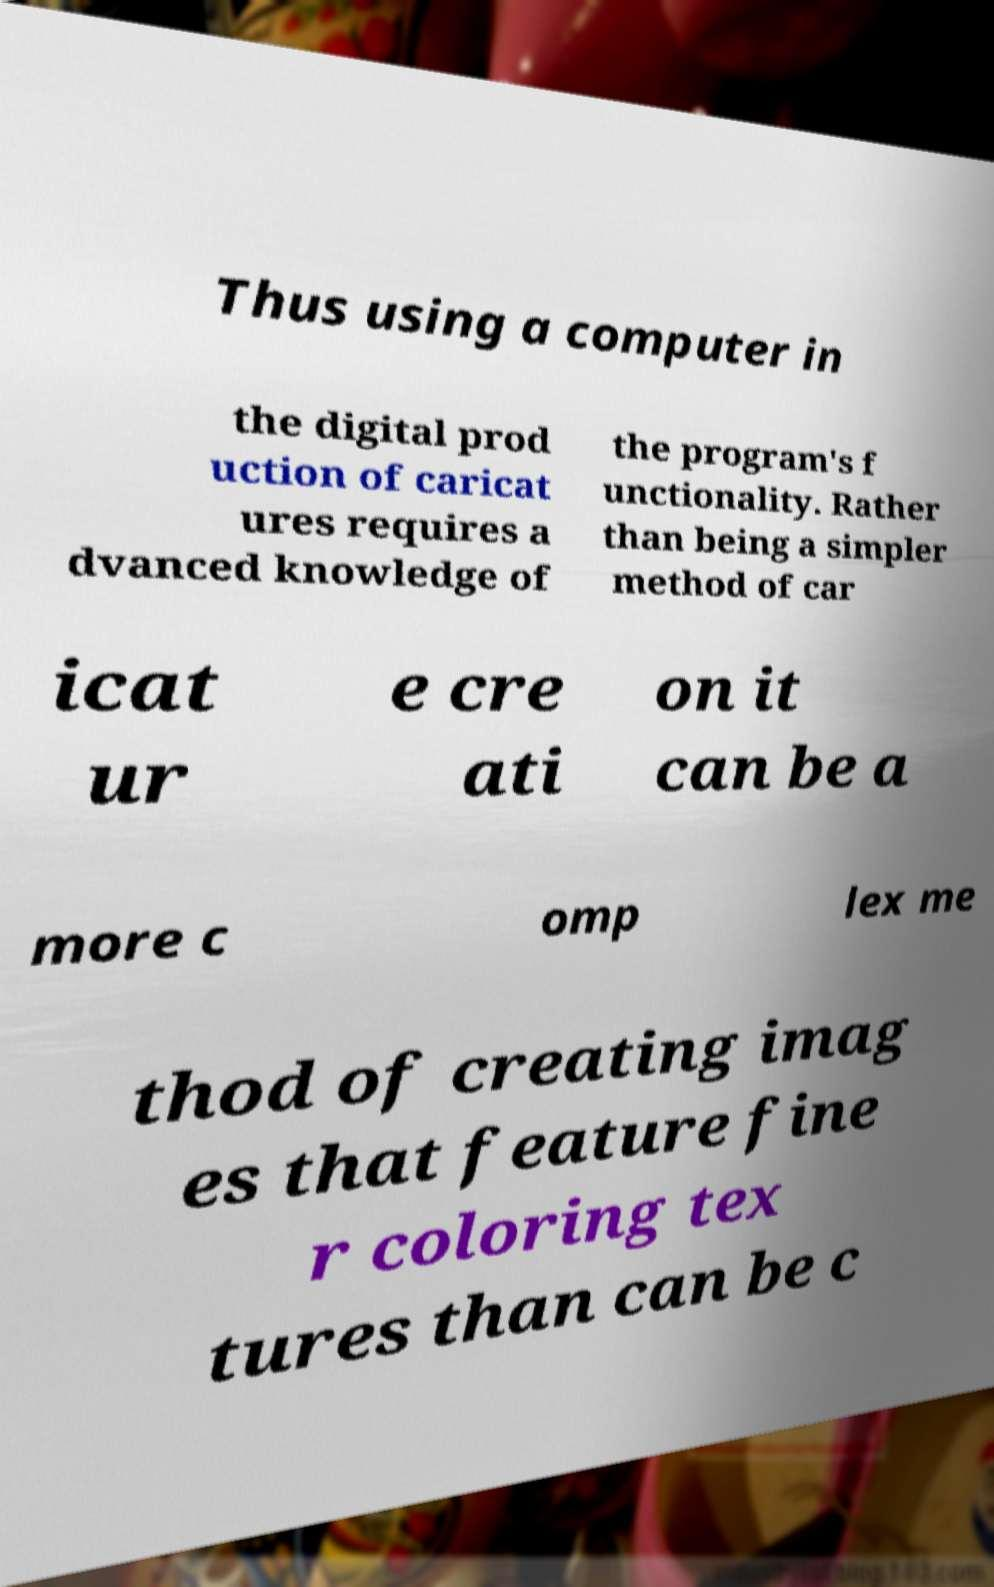Could you assist in decoding the text presented in this image and type it out clearly? Thus using a computer in the digital prod uction of caricat ures requires a dvanced knowledge of the program's f unctionality. Rather than being a simpler method of car icat ur e cre ati on it can be a more c omp lex me thod of creating imag es that feature fine r coloring tex tures than can be c 